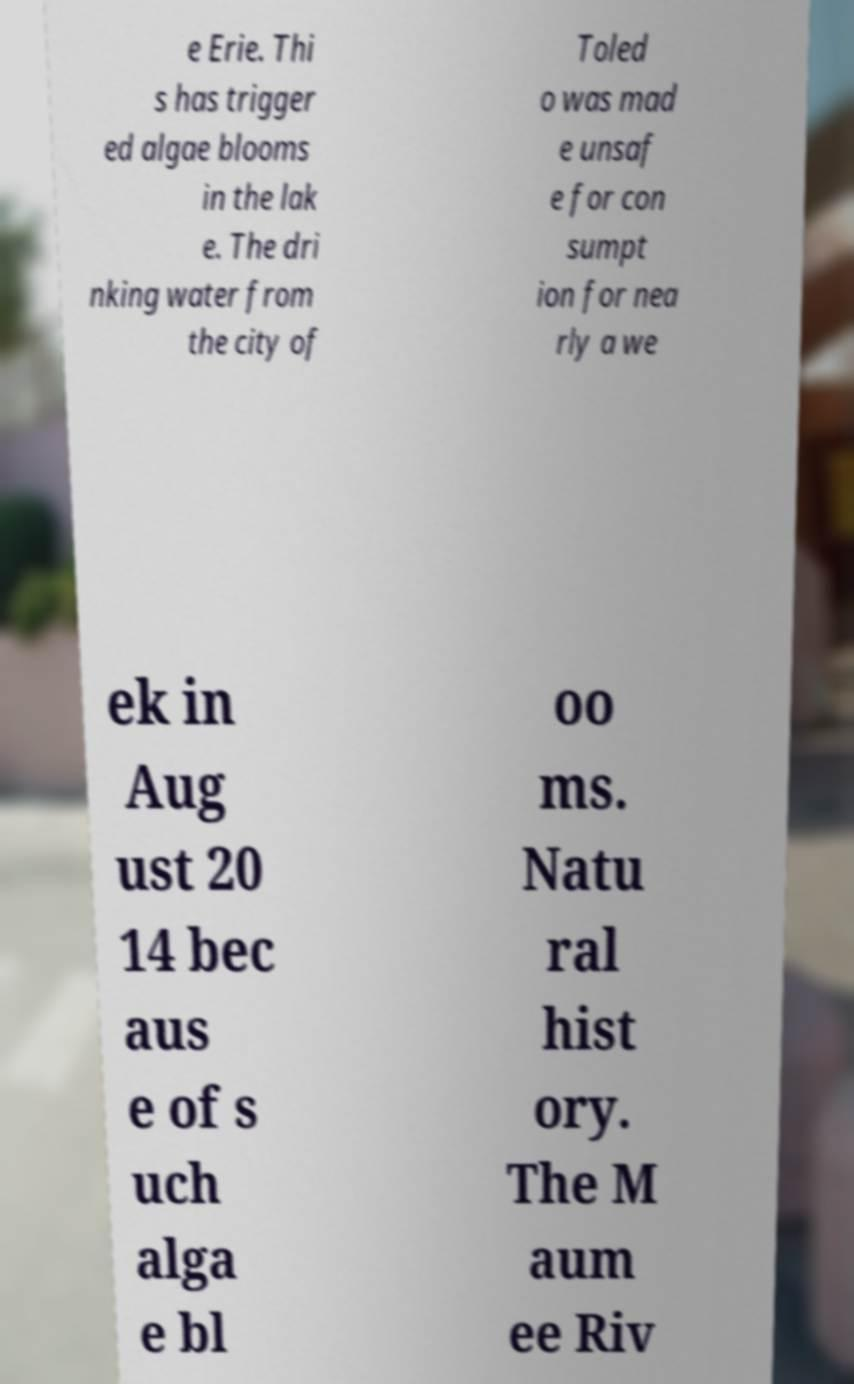What messages or text are displayed in this image? I need them in a readable, typed format. e Erie. Thi s has trigger ed algae blooms in the lak e. The dri nking water from the city of Toled o was mad e unsaf e for con sumpt ion for nea rly a we ek in Aug ust 20 14 bec aus e of s uch alga e bl oo ms. Natu ral hist ory. The M aum ee Riv 